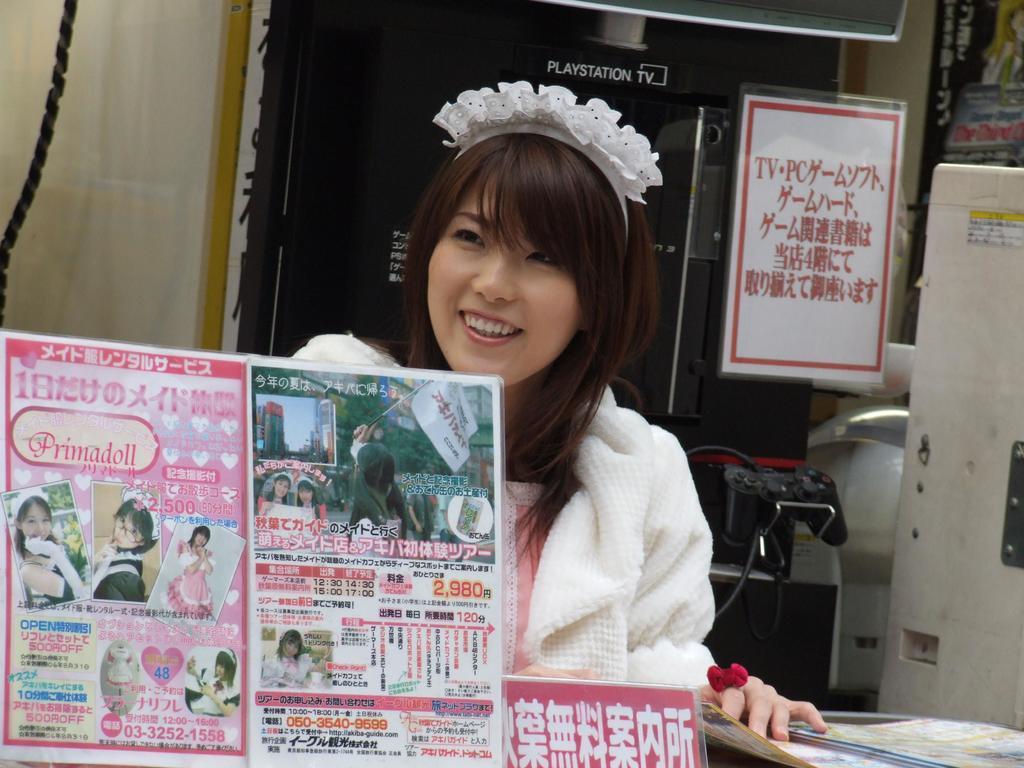How would you summarize this image in a sentence or two? In the foreground of this image, there are few boards on the table. Behind it, there is a woman holding a book like an object. In the background, there is a play station TV, a board, a white color object on the right, remote, cables, poster, curtain, a rope and an object at the top. 